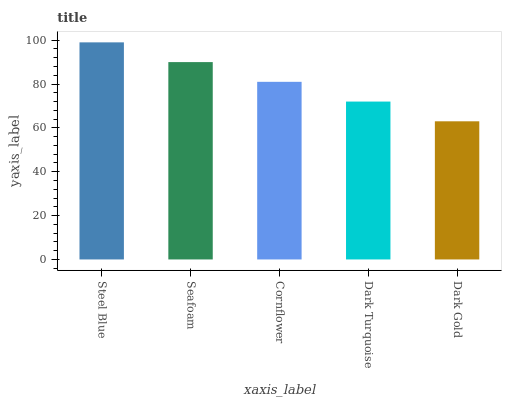Is Dark Gold the minimum?
Answer yes or no. Yes. Is Steel Blue the maximum?
Answer yes or no. Yes. Is Seafoam the minimum?
Answer yes or no. No. Is Seafoam the maximum?
Answer yes or no. No. Is Steel Blue greater than Seafoam?
Answer yes or no. Yes. Is Seafoam less than Steel Blue?
Answer yes or no. Yes. Is Seafoam greater than Steel Blue?
Answer yes or no. No. Is Steel Blue less than Seafoam?
Answer yes or no. No. Is Cornflower the high median?
Answer yes or no. Yes. Is Cornflower the low median?
Answer yes or no. Yes. Is Seafoam the high median?
Answer yes or no. No. Is Dark Gold the low median?
Answer yes or no. No. 